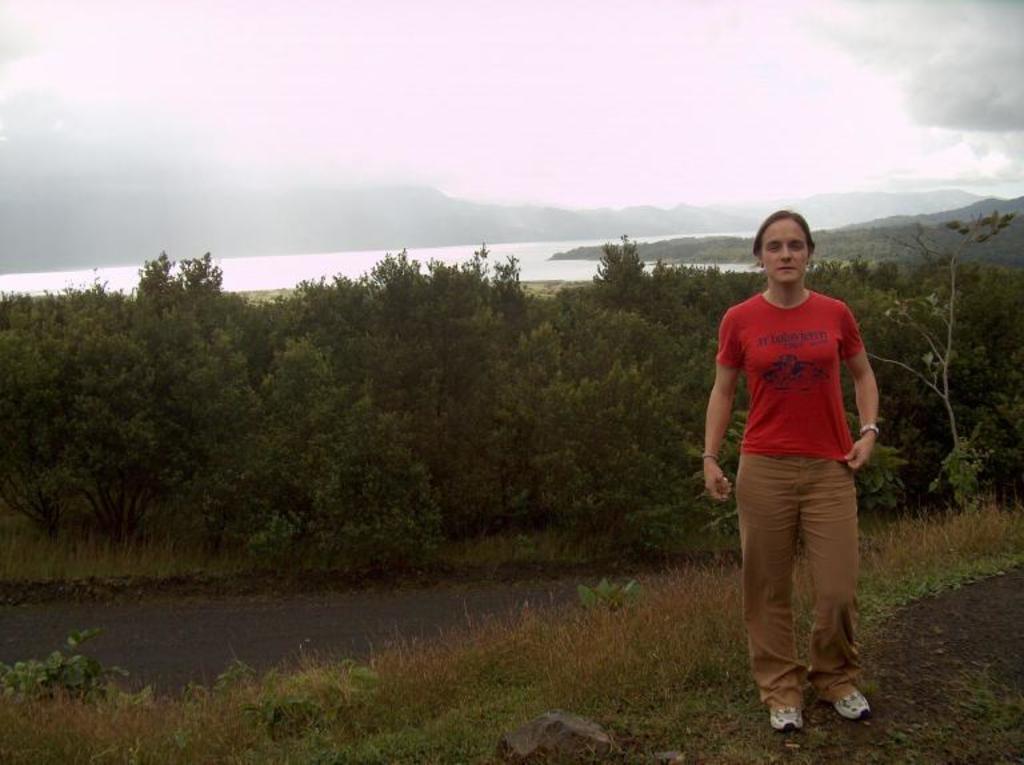Describe this image in one or two sentences. In this picture we can see a person standing in red color t shirt. she wear shoes. This is the grass. And we can see many trees here. This is road. And on the background there is a sky. 